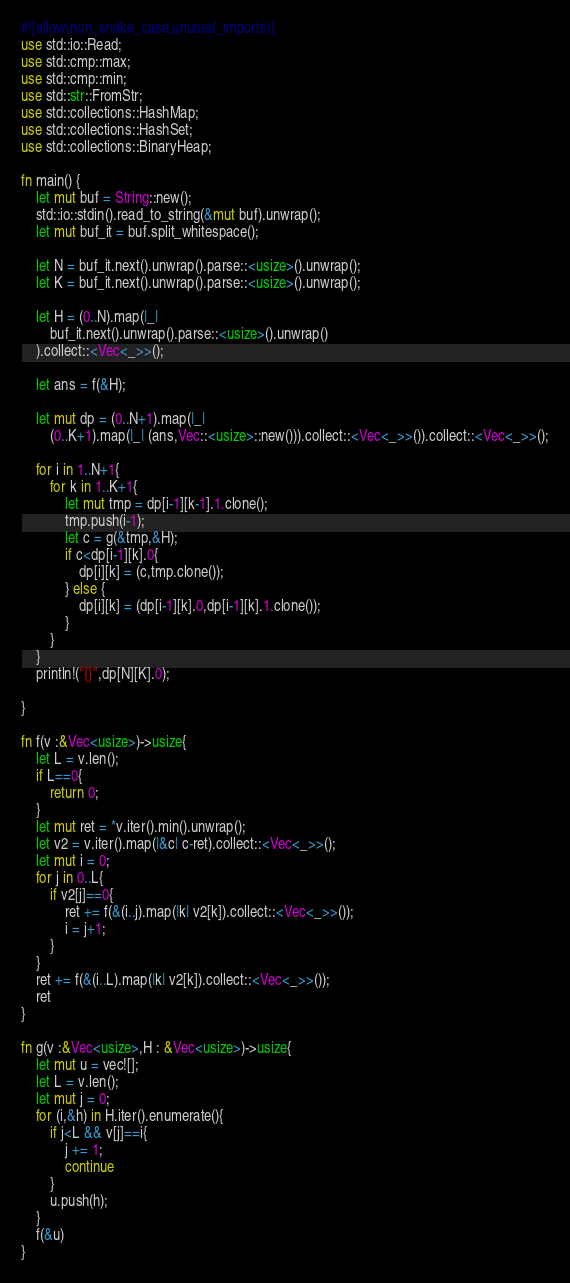Convert code to text. <code><loc_0><loc_0><loc_500><loc_500><_Rust_>#![allow(non_snake_case,unused_imports)]
use std::io::Read;
use std::cmp::max;
use std::cmp::min;
use std::str::FromStr;
use std::collections::HashMap;
use std::collections::HashSet;
use std::collections::BinaryHeap;

fn main() {
    let mut buf = String::new();
    std::io::stdin().read_to_string(&mut buf).unwrap();
    let mut buf_it = buf.split_whitespace();

    let N = buf_it.next().unwrap().parse::<usize>().unwrap();
    let K = buf_it.next().unwrap().parse::<usize>().unwrap();

    let H = (0..N).map(|_| 
        buf_it.next().unwrap().parse::<usize>().unwrap()
    ).collect::<Vec<_>>();

    let ans = f(&H);

    let mut dp = (0..N+1).map(|_|
        (0..K+1).map(|_| (ans,Vec::<usize>::new())).collect::<Vec<_>>()).collect::<Vec<_>>();

    for i in 1..N+1{
        for k in 1..K+1{
            let mut tmp = dp[i-1][k-1].1.clone();
            tmp.push(i-1);
            let c = g(&tmp,&H);
            if c<dp[i-1][k].0{
                dp[i][k] = (c,tmp.clone());
            } else {
                dp[i][k] = (dp[i-1][k].0,dp[i-1][k].1.clone());
            }
        }
    }
    println!("{}",dp[N][K].0);

}

fn f(v :&Vec<usize>)->usize{
    let L = v.len();
    if L==0{
        return 0;
    }
    let mut ret = *v.iter().min().unwrap();
    let v2 = v.iter().map(|&c| c-ret).collect::<Vec<_>>();
    let mut i = 0;
    for j in 0..L{
        if v2[j]==0{
            ret += f(&(i..j).map(|k| v2[k]).collect::<Vec<_>>());
            i = j+1;
        }
    }
    ret += f(&(i..L).map(|k| v2[k]).collect::<Vec<_>>());
    ret
}

fn g(v :&Vec<usize>,H : &Vec<usize>)->usize{
    let mut u = vec![];
    let L = v.len();
    let mut j = 0;
    for (i,&h) in H.iter().enumerate(){
        if j<L && v[j]==i{
            j += 1;
            continue
        }
        u.push(h);
    }
    f(&u)
}</code> 